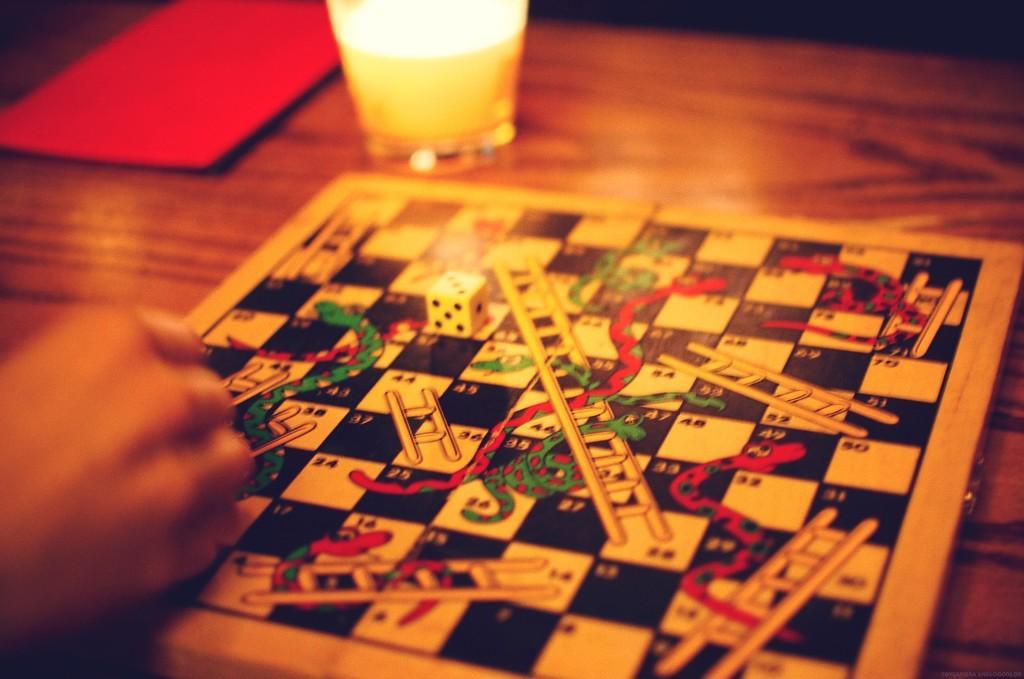How would you summarize this image in a sentence or two? It is a table there is a candle and snake and ladder board kept on the table there is also a die on the table , it means someone is playing the game there is also a red color card on the table. 